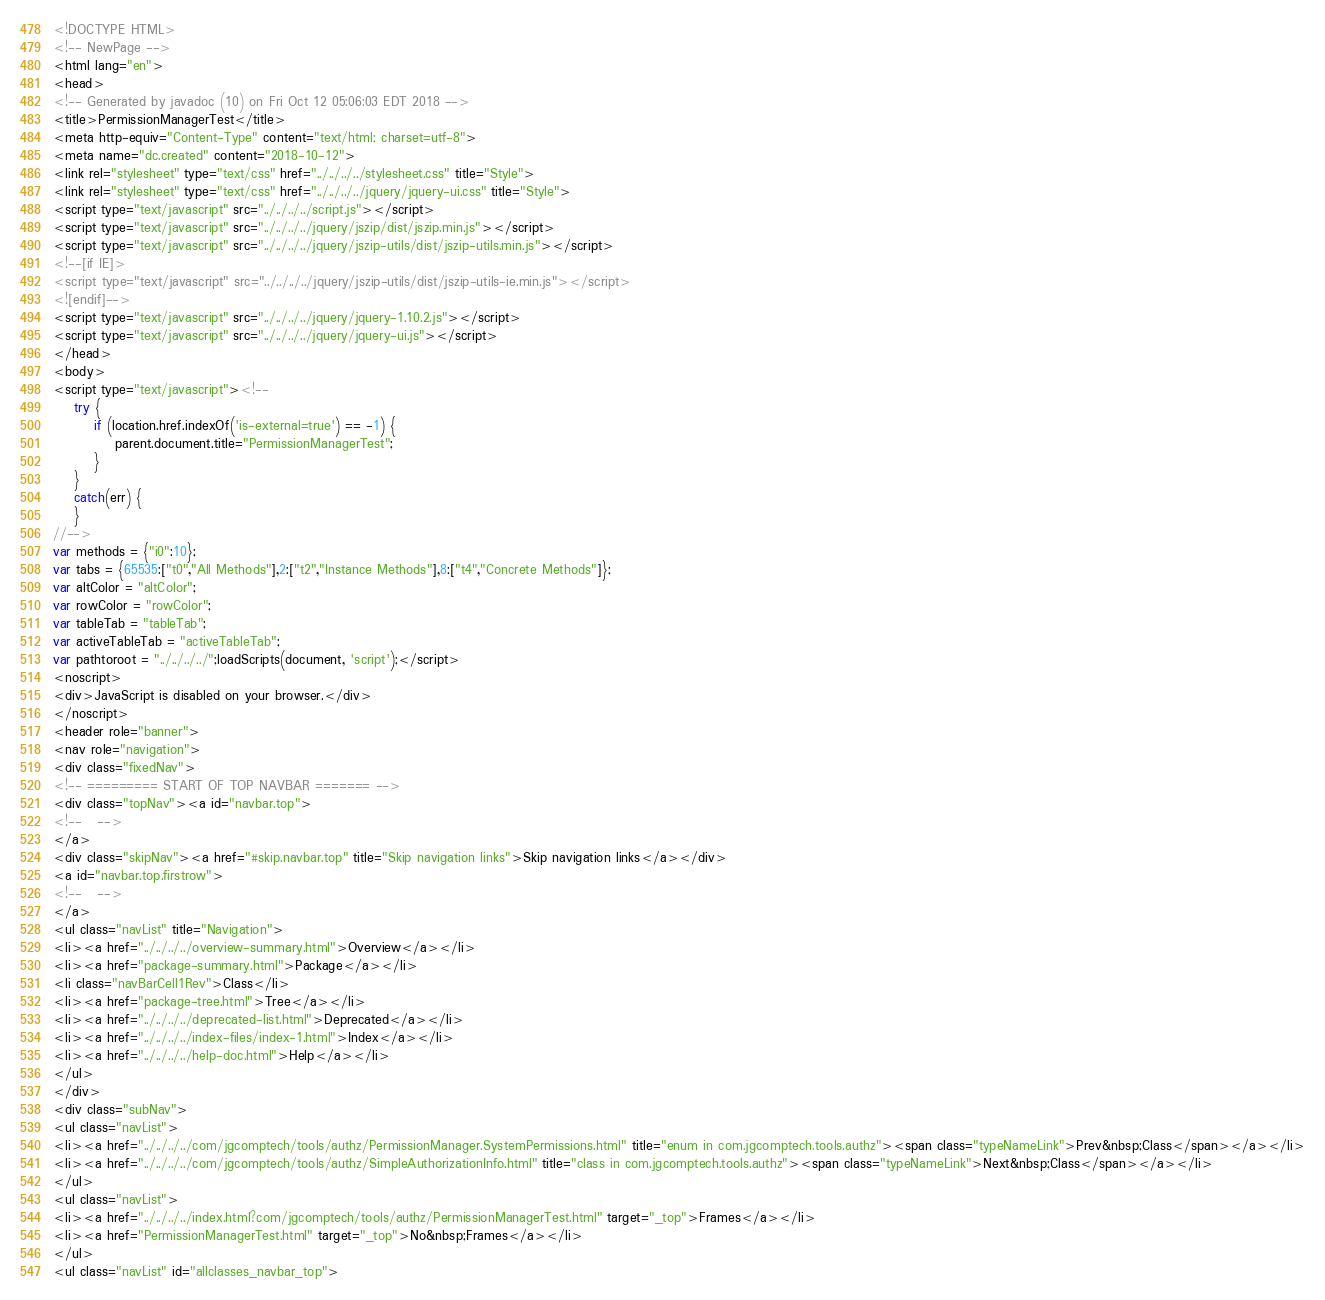<code> <loc_0><loc_0><loc_500><loc_500><_HTML_><!DOCTYPE HTML>
<!-- NewPage -->
<html lang="en">
<head>
<!-- Generated by javadoc (10) on Fri Oct 12 05:06:03 EDT 2018 -->
<title>PermissionManagerTest</title>
<meta http-equiv="Content-Type" content="text/html; charset=utf-8">
<meta name="dc.created" content="2018-10-12">
<link rel="stylesheet" type="text/css" href="../../../../stylesheet.css" title="Style">
<link rel="stylesheet" type="text/css" href="../../../../jquery/jquery-ui.css" title="Style">
<script type="text/javascript" src="../../../../script.js"></script>
<script type="text/javascript" src="../../../../jquery/jszip/dist/jszip.min.js"></script>
<script type="text/javascript" src="../../../../jquery/jszip-utils/dist/jszip-utils.min.js"></script>
<!--[if IE]>
<script type="text/javascript" src="../../../../jquery/jszip-utils/dist/jszip-utils-ie.min.js"></script>
<![endif]-->
<script type="text/javascript" src="../../../../jquery/jquery-1.10.2.js"></script>
<script type="text/javascript" src="../../../../jquery/jquery-ui.js"></script>
</head>
<body>
<script type="text/javascript"><!--
    try {
        if (location.href.indexOf('is-external=true') == -1) {
            parent.document.title="PermissionManagerTest";
        }
    }
    catch(err) {
    }
//-->
var methods = {"i0":10};
var tabs = {65535:["t0","All Methods"],2:["t2","Instance Methods"],8:["t4","Concrete Methods"]};
var altColor = "altColor";
var rowColor = "rowColor";
var tableTab = "tableTab";
var activeTableTab = "activeTableTab";
var pathtoroot = "../../../../";loadScripts(document, 'script');</script>
<noscript>
<div>JavaScript is disabled on your browser.</div>
</noscript>
<header role="banner">
<nav role="navigation">
<div class="fixedNav">
<!-- ========= START OF TOP NAVBAR ======= -->
<div class="topNav"><a id="navbar.top">
<!--   -->
</a>
<div class="skipNav"><a href="#skip.navbar.top" title="Skip navigation links">Skip navigation links</a></div>
<a id="navbar.top.firstrow">
<!--   -->
</a>
<ul class="navList" title="Navigation">
<li><a href="../../../../overview-summary.html">Overview</a></li>
<li><a href="package-summary.html">Package</a></li>
<li class="navBarCell1Rev">Class</li>
<li><a href="package-tree.html">Tree</a></li>
<li><a href="../../../../deprecated-list.html">Deprecated</a></li>
<li><a href="../../../../index-files/index-1.html">Index</a></li>
<li><a href="../../../../help-doc.html">Help</a></li>
</ul>
</div>
<div class="subNav">
<ul class="navList">
<li><a href="../../../../com/jgcomptech/tools/authz/PermissionManager.SystemPermissions.html" title="enum in com.jgcomptech.tools.authz"><span class="typeNameLink">Prev&nbsp;Class</span></a></li>
<li><a href="../../../../com/jgcomptech/tools/authz/SimpleAuthorizationInfo.html" title="class in com.jgcomptech.tools.authz"><span class="typeNameLink">Next&nbsp;Class</span></a></li>
</ul>
<ul class="navList">
<li><a href="../../../../index.html?com/jgcomptech/tools/authz/PermissionManagerTest.html" target="_top">Frames</a></li>
<li><a href="PermissionManagerTest.html" target="_top">No&nbsp;Frames</a></li>
</ul>
<ul class="navList" id="allclasses_navbar_top"></code> 